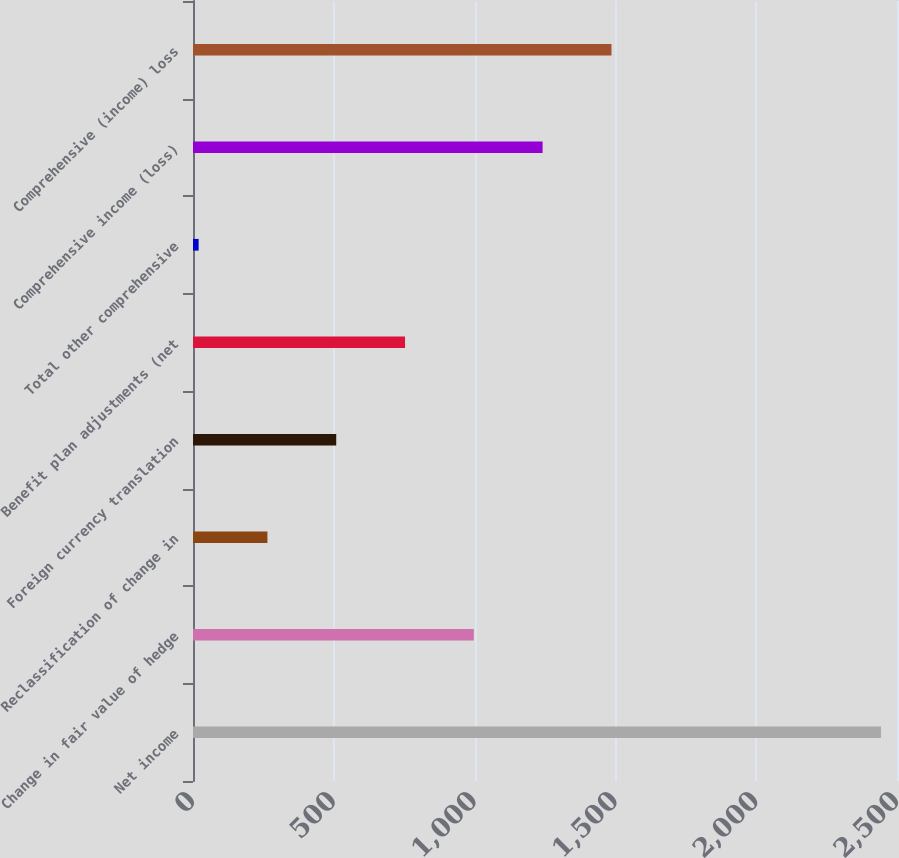Convert chart. <chart><loc_0><loc_0><loc_500><loc_500><bar_chart><fcel>Net income<fcel>Change in fair value of hedge<fcel>Reclassification of change in<fcel>Foreign currency translation<fcel>Benefit plan adjustments (net<fcel>Total other comprehensive<fcel>Comprehensive income (loss)<fcel>Comprehensive (income) loss<nl><fcel>2443<fcel>997.2<fcel>264.3<fcel>508.6<fcel>752.9<fcel>20<fcel>1241.5<fcel>1486<nl></chart> 